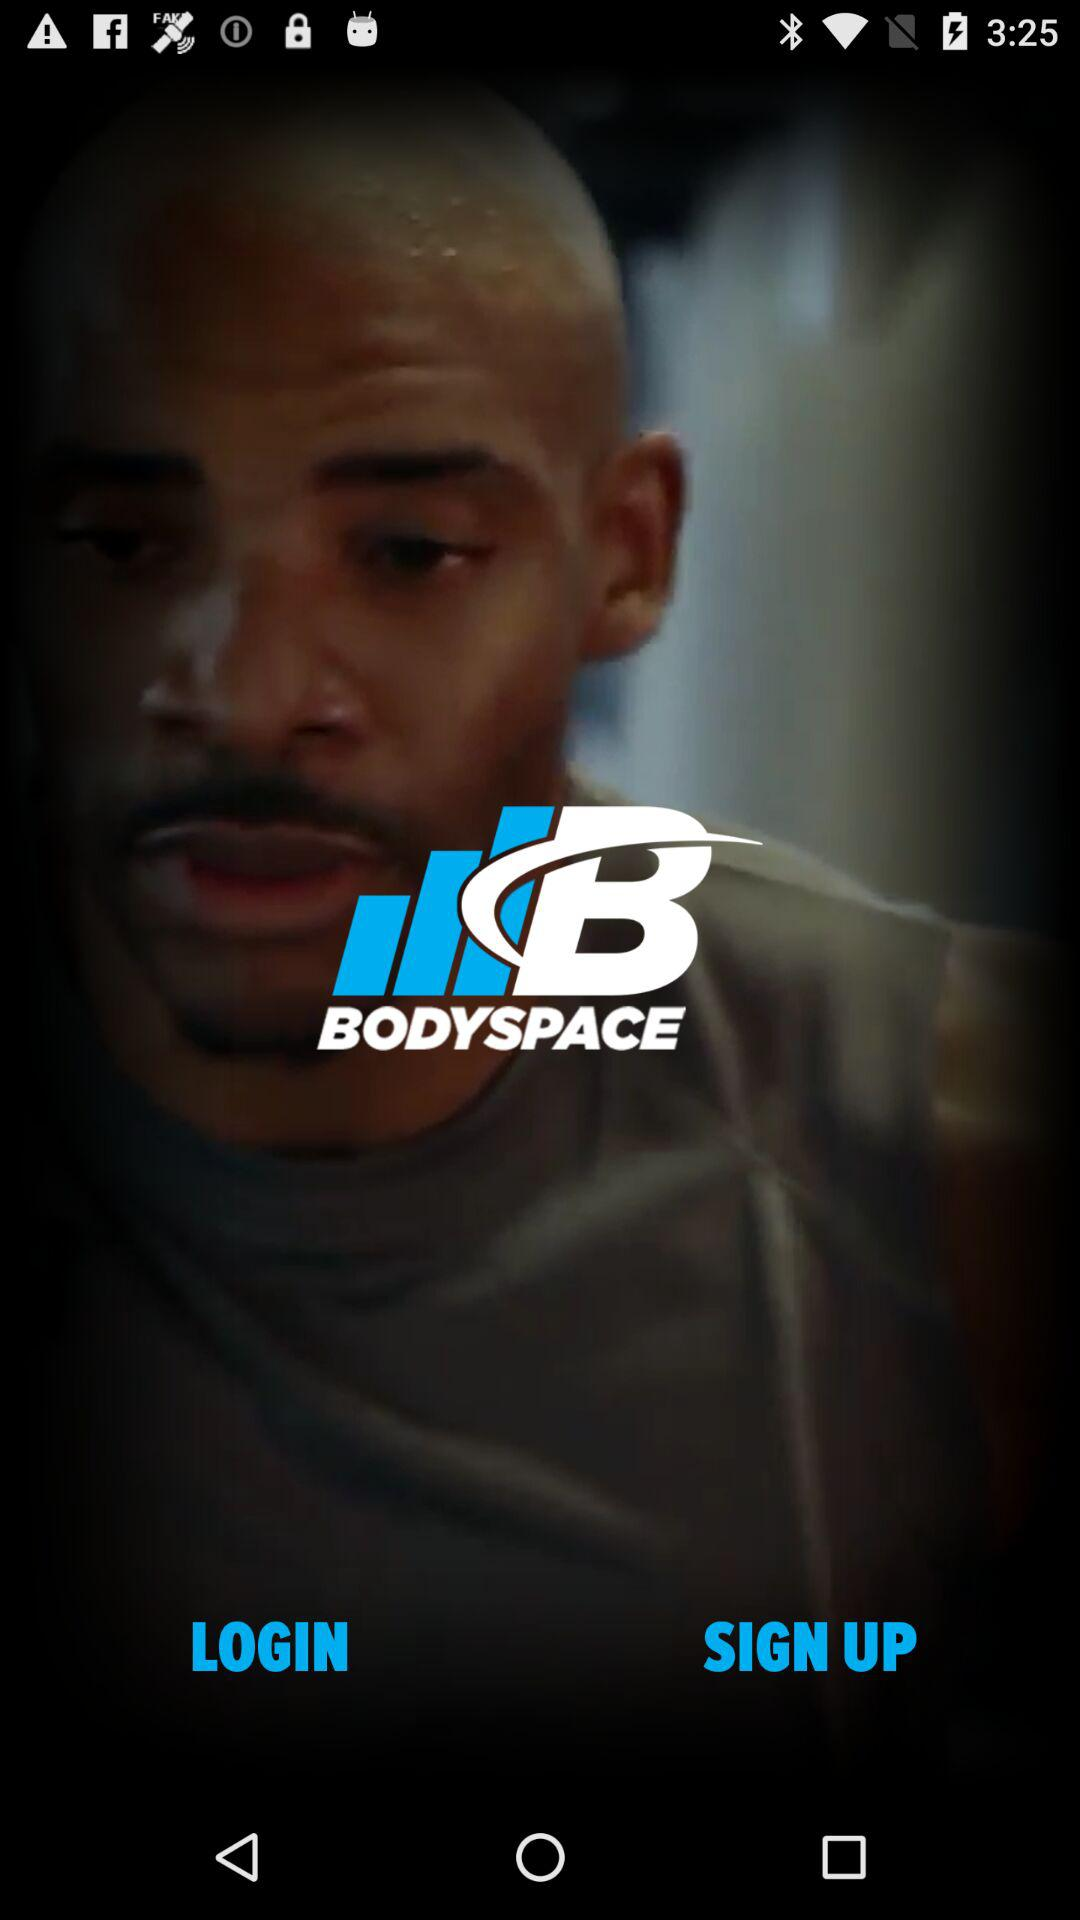What is the name of the application? The name of the application is "BODYSPACE". 